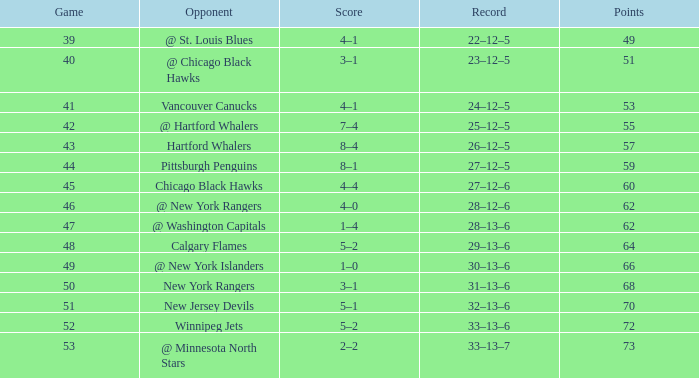Can you parse all the data within this table? {'header': ['Game', 'Opponent', 'Score', 'Record', 'Points'], 'rows': [['39', '@ St. Louis Blues', '4–1', '22–12–5', '49'], ['40', '@ Chicago Black Hawks', '3–1', '23–12–5', '51'], ['41', 'Vancouver Canucks', '4–1', '24–12–5', '53'], ['42', '@ Hartford Whalers', '7–4', '25–12–5', '55'], ['43', 'Hartford Whalers', '8–4', '26–12–5', '57'], ['44', 'Pittsburgh Penguins', '8–1', '27–12–5', '59'], ['45', 'Chicago Black Hawks', '4–4', '27–12–6', '60'], ['46', '@ New York Rangers', '4–0', '28–12–6', '62'], ['47', '@ Washington Capitals', '1–4', '28–13–6', '62'], ['48', 'Calgary Flames', '5–2', '29–13–6', '64'], ['49', '@ New York Islanders', '1–0', '30–13–6', '66'], ['50', 'New York Rangers', '3–1', '31–13–6', '68'], ['51', 'New Jersey Devils', '5–1', '32–13–6', '70'], ['52', 'Winnipeg Jets', '5–2', '33–13–6', '72'], ['53', '@ Minnesota North Stars', '2–2', '33–13–7', '73']]} Which Points have a Score of 4–1, and a Game smaller than 39? None. 